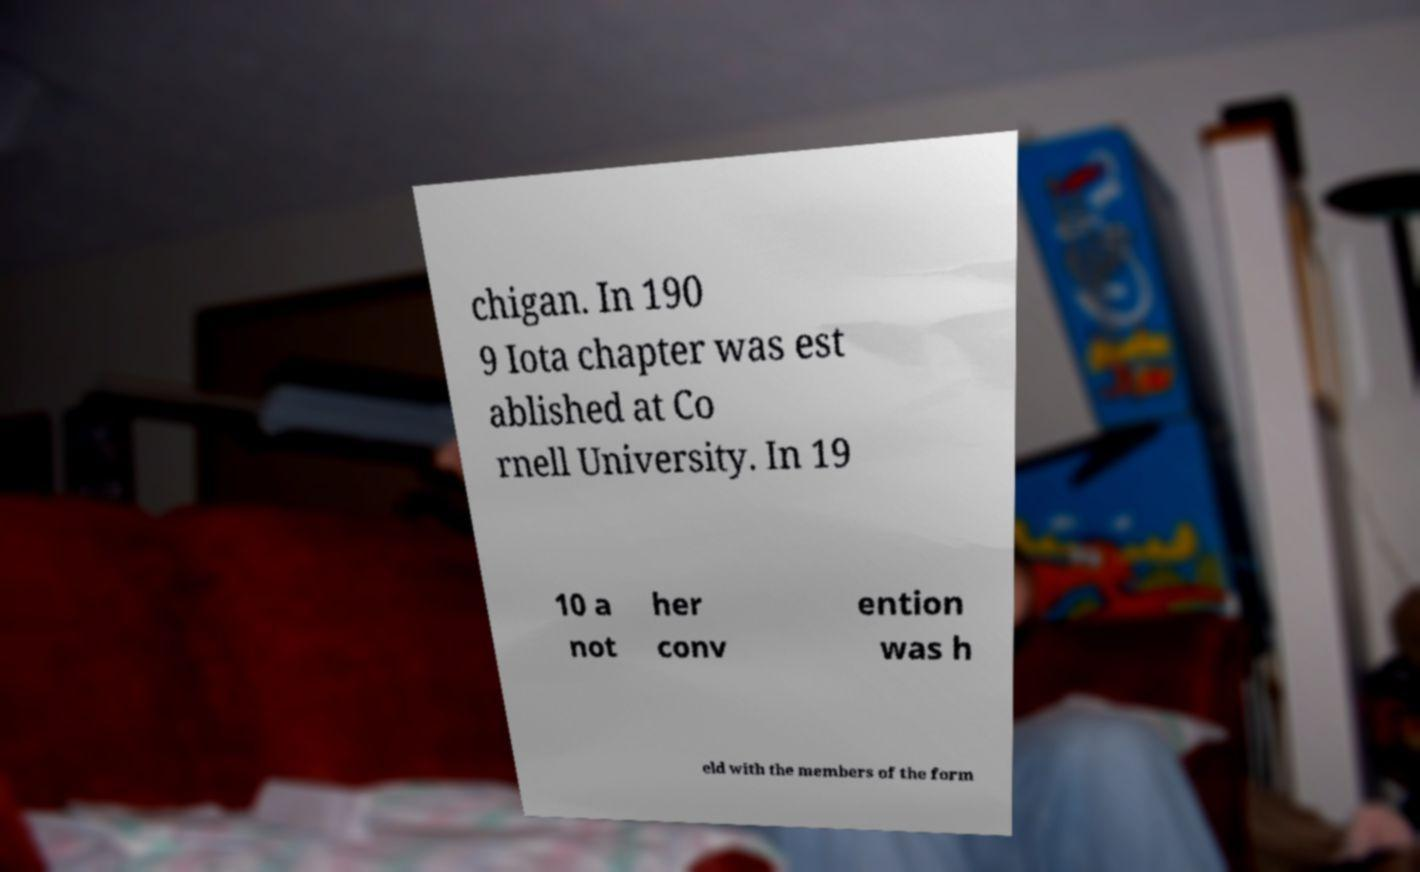Can you read and provide the text displayed in the image?This photo seems to have some interesting text. Can you extract and type it out for me? chigan. In 190 9 Iota chapter was est ablished at Co rnell University. In 19 10 a not her conv ention was h eld with the members of the form 